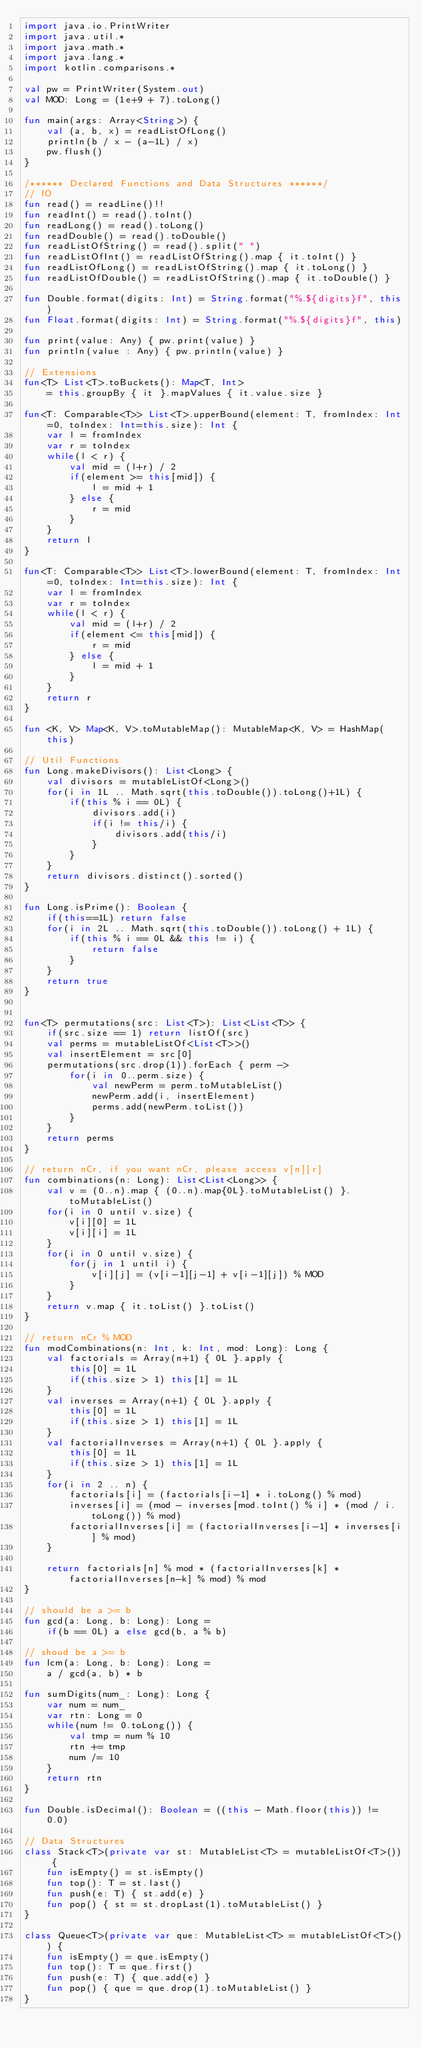<code> <loc_0><loc_0><loc_500><loc_500><_Kotlin_>import java.io.PrintWriter
import java.util.*
import java.math.*
import java.lang.*
import kotlin.comparisons.*

val pw = PrintWriter(System.out)
val MOD: Long = (1e+9 + 7).toLong()

fun main(args: Array<String>) {
    val (a, b, x) = readListOfLong()
    println(b / x - (a-1L) / x)
    pw.flush()
}

/****** Declared Functions and Data Structures ******/
// IO
fun read() = readLine()!!
fun readInt() = read().toInt()
fun readLong() = read().toLong()
fun readDouble() = read().toDouble()
fun readListOfString() = read().split(" ")
fun readListOfInt() = readListOfString().map { it.toInt() }
fun readListOfLong() = readListOfString().map { it.toLong() }
fun readListOfDouble() = readListOfString().map { it.toDouble() }

fun Double.format(digits: Int) = String.format("%.${digits}f", this)
fun Float.format(digits: Int) = String.format("%.${digits}f", this)

fun print(value: Any) { pw.print(value) }
fun println(value : Any) { pw.println(value) }

// Extensions
fun<T> List<T>.toBuckets(): Map<T, Int>
    = this.groupBy { it }.mapValues { it.value.size }

fun<T: Comparable<T>> List<T>.upperBound(element: T, fromIndex: Int=0, toIndex: Int=this.size): Int {
    var l = fromIndex
    var r = toIndex
    while(l < r) {
        val mid = (l+r) / 2
        if(element >= this[mid]) { 
            l = mid + 1
        } else {
            r = mid
        }
    }
    return l
}

fun<T: Comparable<T>> List<T>.lowerBound(element: T, fromIndex: Int=0, toIndex: Int=this.size): Int {
    var l = fromIndex
    var r = toIndex
    while(l < r) {
        val mid = (l+r) / 2
        if(element <= this[mid]) { 
            r = mid
        } else {
            l = mid + 1
        }
    }
    return r 
}

fun <K, V> Map<K, V>.toMutableMap(): MutableMap<K, V> = HashMap(this)

// Util Functions
fun Long.makeDivisors(): List<Long> {
    val divisors = mutableListOf<Long>()
    for(i in 1L .. Math.sqrt(this.toDouble()).toLong()+1L) {
        if(this % i == 0L) {
            divisors.add(i)
            if(i != this/i) {
                divisors.add(this/i)
            }
        }
    }
    return divisors.distinct().sorted()
}

fun Long.isPrime(): Boolean {
    if(this==1L) return false
    for(i in 2L .. Math.sqrt(this.toDouble()).toLong() + 1L) {
        if(this % i == 0L && this != i) {
            return false
        }
    }
    return true
}


fun<T> permutations(src: List<T>): List<List<T>> {
    if(src.size == 1) return listOf(src)
    val perms = mutableListOf<List<T>>()
    val insertElement = src[0]
    permutations(src.drop(1)).forEach { perm ->
        for(i in 0..perm.size) {
            val newPerm = perm.toMutableList()
            newPerm.add(i, insertElement)
            perms.add(newPerm.toList())
        }
    }
    return perms
}

// return nCr, if you want nCr, please access v[n][r]
fun combinations(n: Long): List<List<Long>> {
    val v = (0..n).map { (0..n).map{0L}.toMutableList() }.toMutableList()
    for(i in 0 until v.size) {
        v[i][0] = 1L
        v[i][i] = 1L
    }
    for(i in 0 until v.size) {
        for(j in 1 until i) {
            v[i][j] = (v[i-1][j-1] + v[i-1][j]) % MOD
        }
    }
    return v.map { it.toList() }.toList()
}

// return nCr % MOD
fun modCombinations(n: Int, k: Int, mod: Long): Long {
    val factorials = Array(n+1) { 0L }.apply {
        this[0] = 1L
        if(this.size > 1) this[1] = 1L
    }
    val inverses = Array(n+1) { 0L }.apply {
        this[0] = 1L
        if(this.size > 1) this[1] = 1L
    }
    val factorialInverses = Array(n+1) { 0L }.apply {
        this[0] = 1L
        if(this.size > 1) this[1] = 1L
    }
    for(i in 2 .. n) {
        factorials[i] = (factorials[i-1] * i.toLong() % mod)
        inverses[i] = (mod - inverses[mod.toInt() % i] * (mod / i.toLong()) % mod)
        factorialInverses[i] = (factorialInverses[i-1] * inverses[i] % mod)
    }

    return factorials[n] % mod * (factorialInverses[k] * factorialInverses[n-k] % mod) % mod
}

// should be a >= b
fun gcd(a: Long, b: Long): Long = 
    if(b == 0L) a else gcd(b, a % b)

// shoud be a >= b
fun lcm(a: Long, b: Long): Long = 
    a / gcd(a, b) * b

fun sumDigits(num_: Long): Long {
    var num = num_
    var rtn: Long = 0
    while(num != 0.toLong()) {
        val tmp = num % 10
        rtn += tmp
        num /= 10
    }
    return rtn
}

fun Double.isDecimal(): Boolean = ((this - Math.floor(this)) != 0.0)

// Data Structures
class Stack<T>(private var st: MutableList<T> = mutableListOf<T>()) {
    fun isEmpty() = st.isEmpty()
    fun top(): T = st.last()
    fun push(e: T) { st.add(e) }
    fun pop() { st = st.dropLast(1).toMutableList() }
}

class Queue<T>(private var que: MutableList<T> = mutableListOf<T>()) {
    fun isEmpty() = que.isEmpty()
    fun top(): T = que.first()
    fun push(e: T) { que.add(e) }
    fun pop() { que = que.drop(1).toMutableList() }
}
</code> 